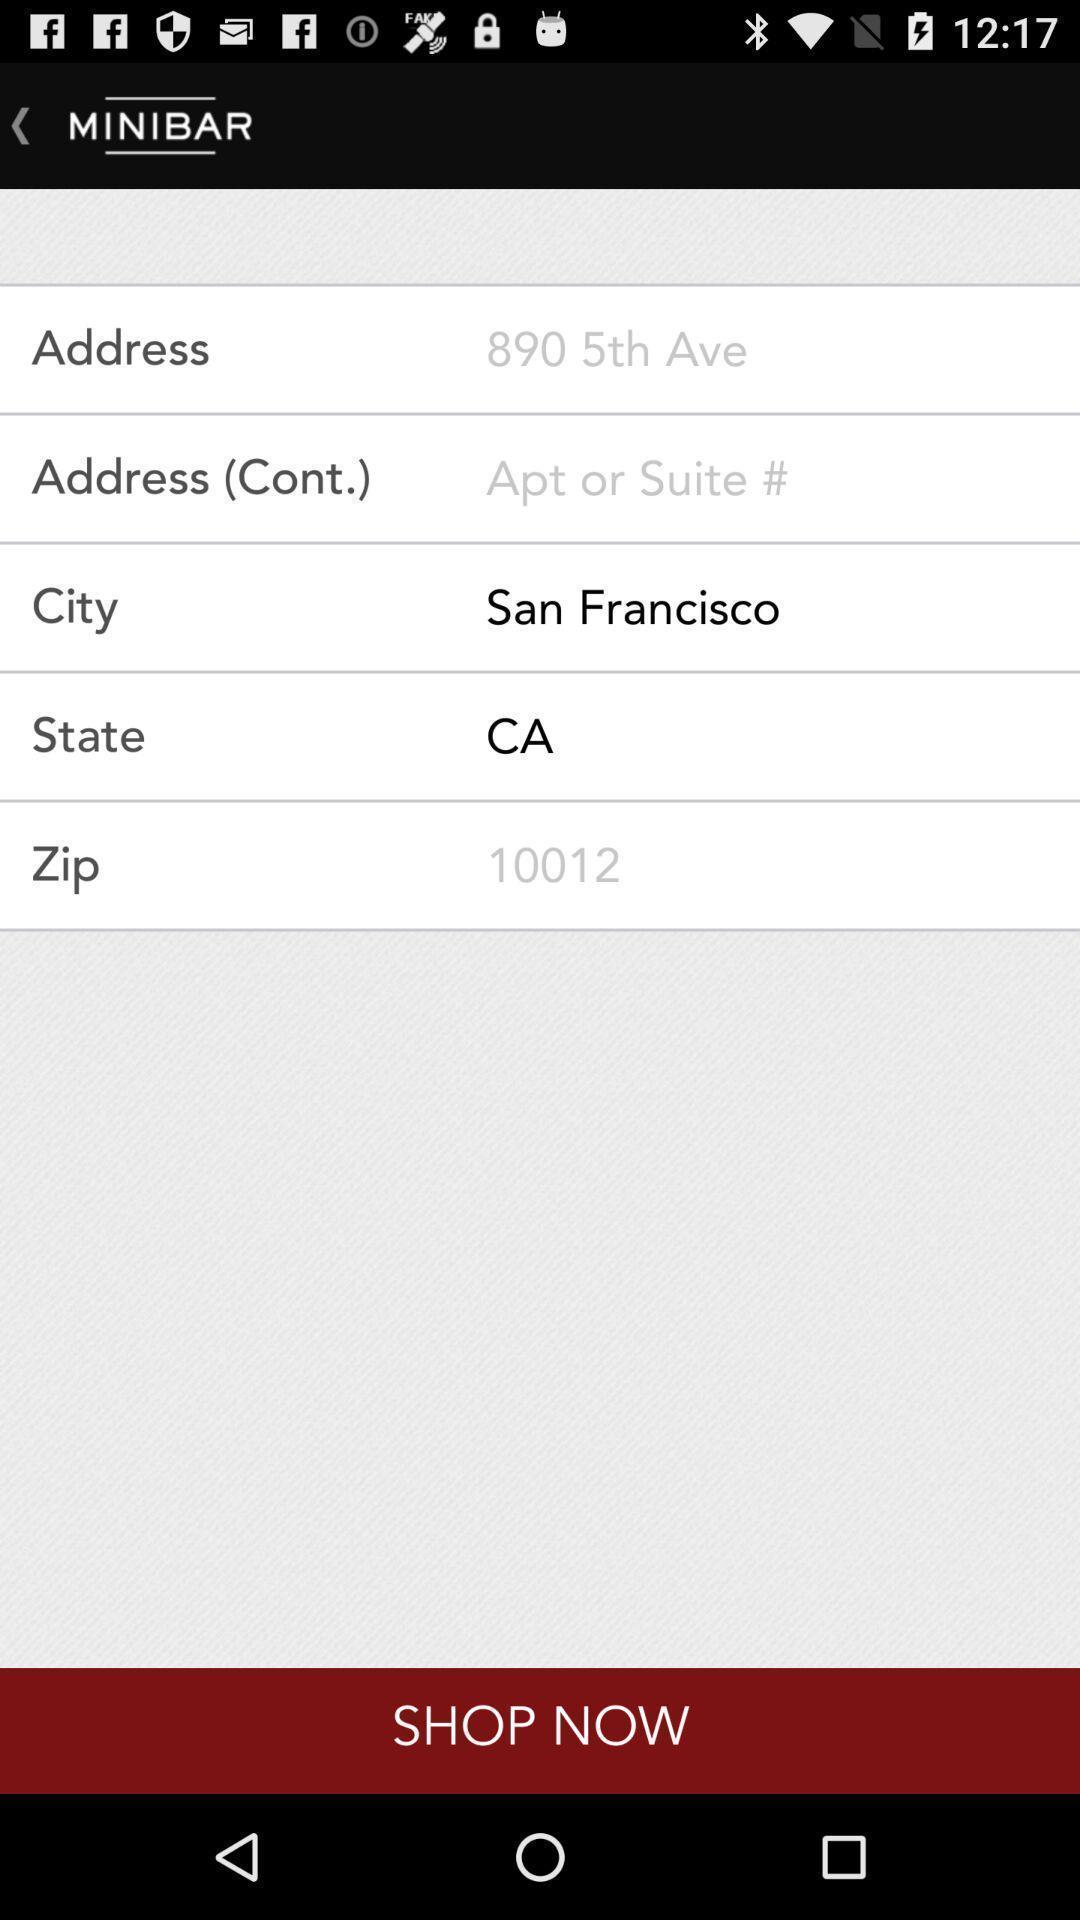What details can you identify in this image? Screen display enter address options. 